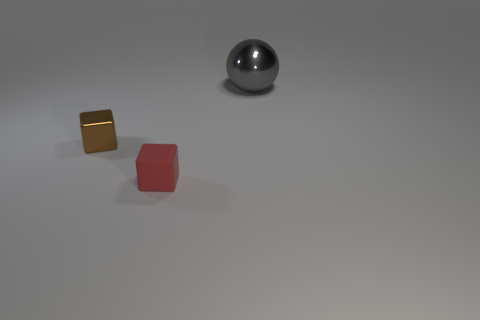Add 1 purple blocks. How many objects exist? 4 Subtract all cubes. How many objects are left? 1 Add 3 brown metallic cubes. How many brown metallic cubes are left? 4 Add 3 metal balls. How many metal balls exist? 4 Subtract 0 cyan blocks. How many objects are left? 3 Subtract all small red matte things. Subtract all large gray metal balls. How many objects are left? 1 